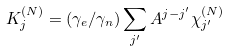<formula> <loc_0><loc_0><loc_500><loc_500>K ^ { ( N ) } _ { j } = ( \gamma _ { e } / \gamma _ { n } ) \sum _ { j ^ { \prime } } A ^ { j - j ^ { \prime } } \chi ^ { ( N ) } _ { j ^ { \prime } }</formula> 